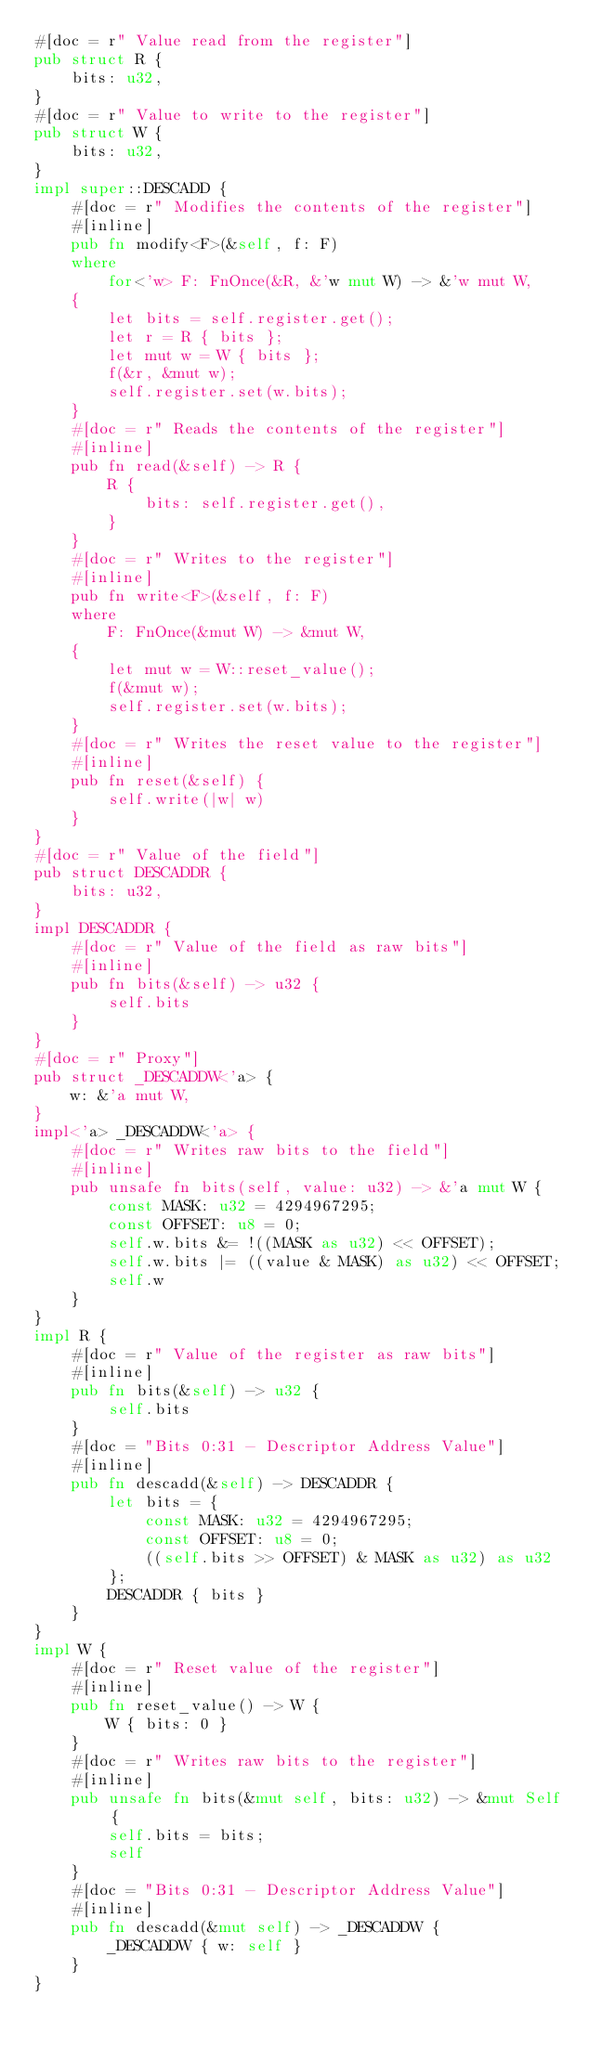<code> <loc_0><loc_0><loc_500><loc_500><_Rust_>#[doc = r" Value read from the register"]
pub struct R {
    bits: u32,
}
#[doc = r" Value to write to the register"]
pub struct W {
    bits: u32,
}
impl super::DESCADD {
    #[doc = r" Modifies the contents of the register"]
    #[inline]
    pub fn modify<F>(&self, f: F)
    where
        for<'w> F: FnOnce(&R, &'w mut W) -> &'w mut W,
    {
        let bits = self.register.get();
        let r = R { bits };
        let mut w = W { bits };
        f(&r, &mut w);
        self.register.set(w.bits);
    }
    #[doc = r" Reads the contents of the register"]
    #[inline]
    pub fn read(&self) -> R {
        R {
            bits: self.register.get(),
        }
    }
    #[doc = r" Writes to the register"]
    #[inline]
    pub fn write<F>(&self, f: F)
    where
        F: FnOnce(&mut W) -> &mut W,
    {
        let mut w = W::reset_value();
        f(&mut w);
        self.register.set(w.bits);
    }
    #[doc = r" Writes the reset value to the register"]
    #[inline]
    pub fn reset(&self) {
        self.write(|w| w)
    }
}
#[doc = r" Value of the field"]
pub struct DESCADDR {
    bits: u32,
}
impl DESCADDR {
    #[doc = r" Value of the field as raw bits"]
    #[inline]
    pub fn bits(&self) -> u32 {
        self.bits
    }
}
#[doc = r" Proxy"]
pub struct _DESCADDW<'a> {
    w: &'a mut W,
}
impl<'a> _DESCADDW<'a> {
    #[doc = r" Writes raw bits to the field"]
    #[inline]
    pub unsafe fn bits(self, value: u32) -> &'a mut W {
        const MASK: u32 = 4294967295;
        const OFFSET: u8 = 0;
        self.w.bits &= !((MASK as u32) << OFFSET);
        self.w.bits |= ((value & MASK) as u32) << OFFSET;
        self.w
    }
}
impl R {
    #[doc = r" Value of the register as raw bits"]
    #[inline]
    pub fn bits(&self) -> u32 {
        self.bits
    }
    #[doc = "Bits 0:31 - Descriptor Address Value"]
    #[inline]
    pub fn descadd(&self) -> DESCADDR {
        let bits = {
            const MASK: u32 = 4294967295;
            const OFFSET: u8 = 0;
            ((self.bits >> OFFSET) & MASK as u32) as u32
        };
        DESCADDR { bits }
    }
}
impl W {
    #[doc = r" Reset value of the register"]
    #[inline]
    pub fn reset_value() -> W {
        W { bits: 0 }
    }
    #[doc = r" Writes raw bits to the register"]
    #[inline]
    pub unsafe fn bits(&mut self, bits: u32) -> &mut Self {
        self.bits = bits;
        self
    }
    #[doc = "Bits 0:31 - Descriptor Address Value"]
    #[inline]
    pub fn descadd(&mut self) -> _DESCADDW {
        _DESCADDW { w: self }
    }
}
</code> 